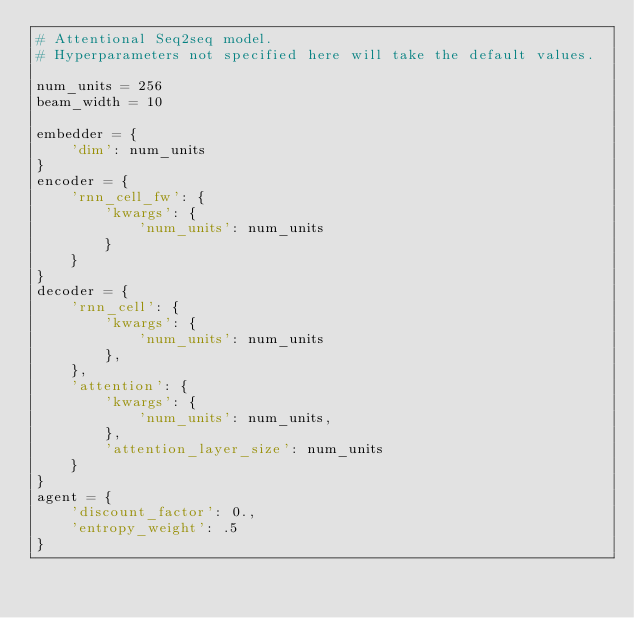Convert code to text. <code><loc_0><loc_0><loc_500><loc_500><_Python_># Attentional Seq2seq model.
# Hyperparameters not specified here will take the default values.

num_units = 256
beam_width = 10

embedder = {
    'dim': num_units
}
encoder = {
    'rnn_cell_fw': {
        'kwargs': {
            'num_units': num_units
        }
    }
}
decoder = {
    'rnn_cell': {
        'kwargs': {
            'num_units': num_units
        },
    },
    'attention': {
        'kwargs': {
            'num_units': num_units,
        },
        'attention_layer_size': num_units
    }
}
agent = {
    'discount_factor': 0.,
    'entropy_weight': .5
}
</code> 